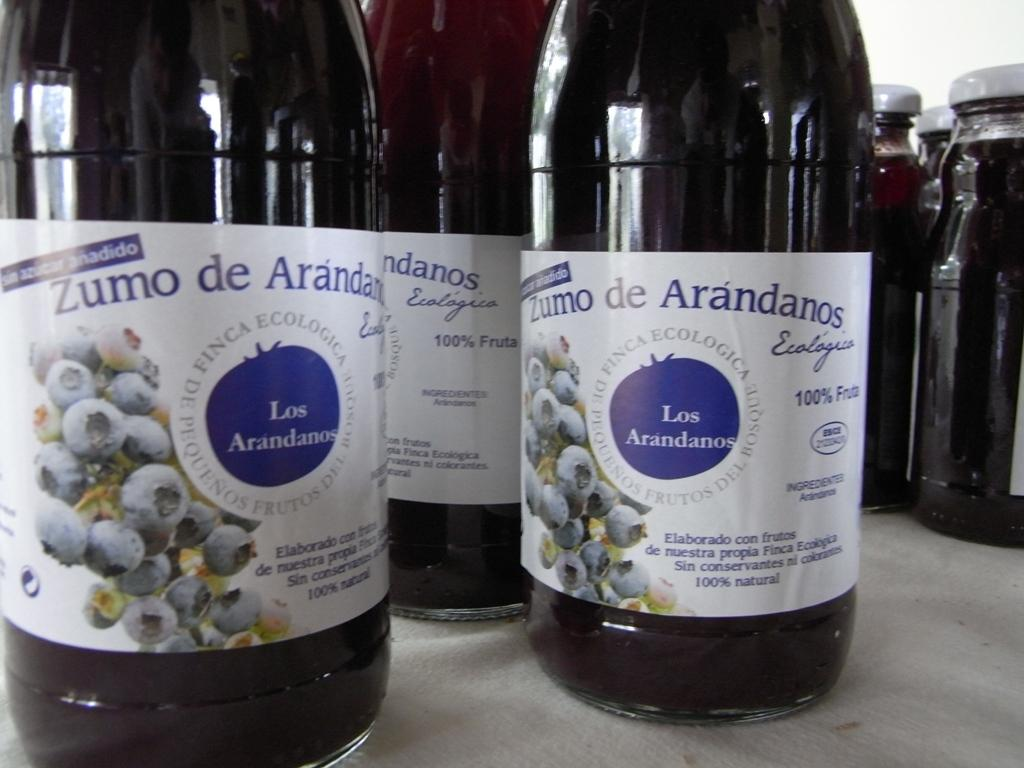Provide a one-sentence caption for the provided image. bottle of zumo de arandanos on the counter. 